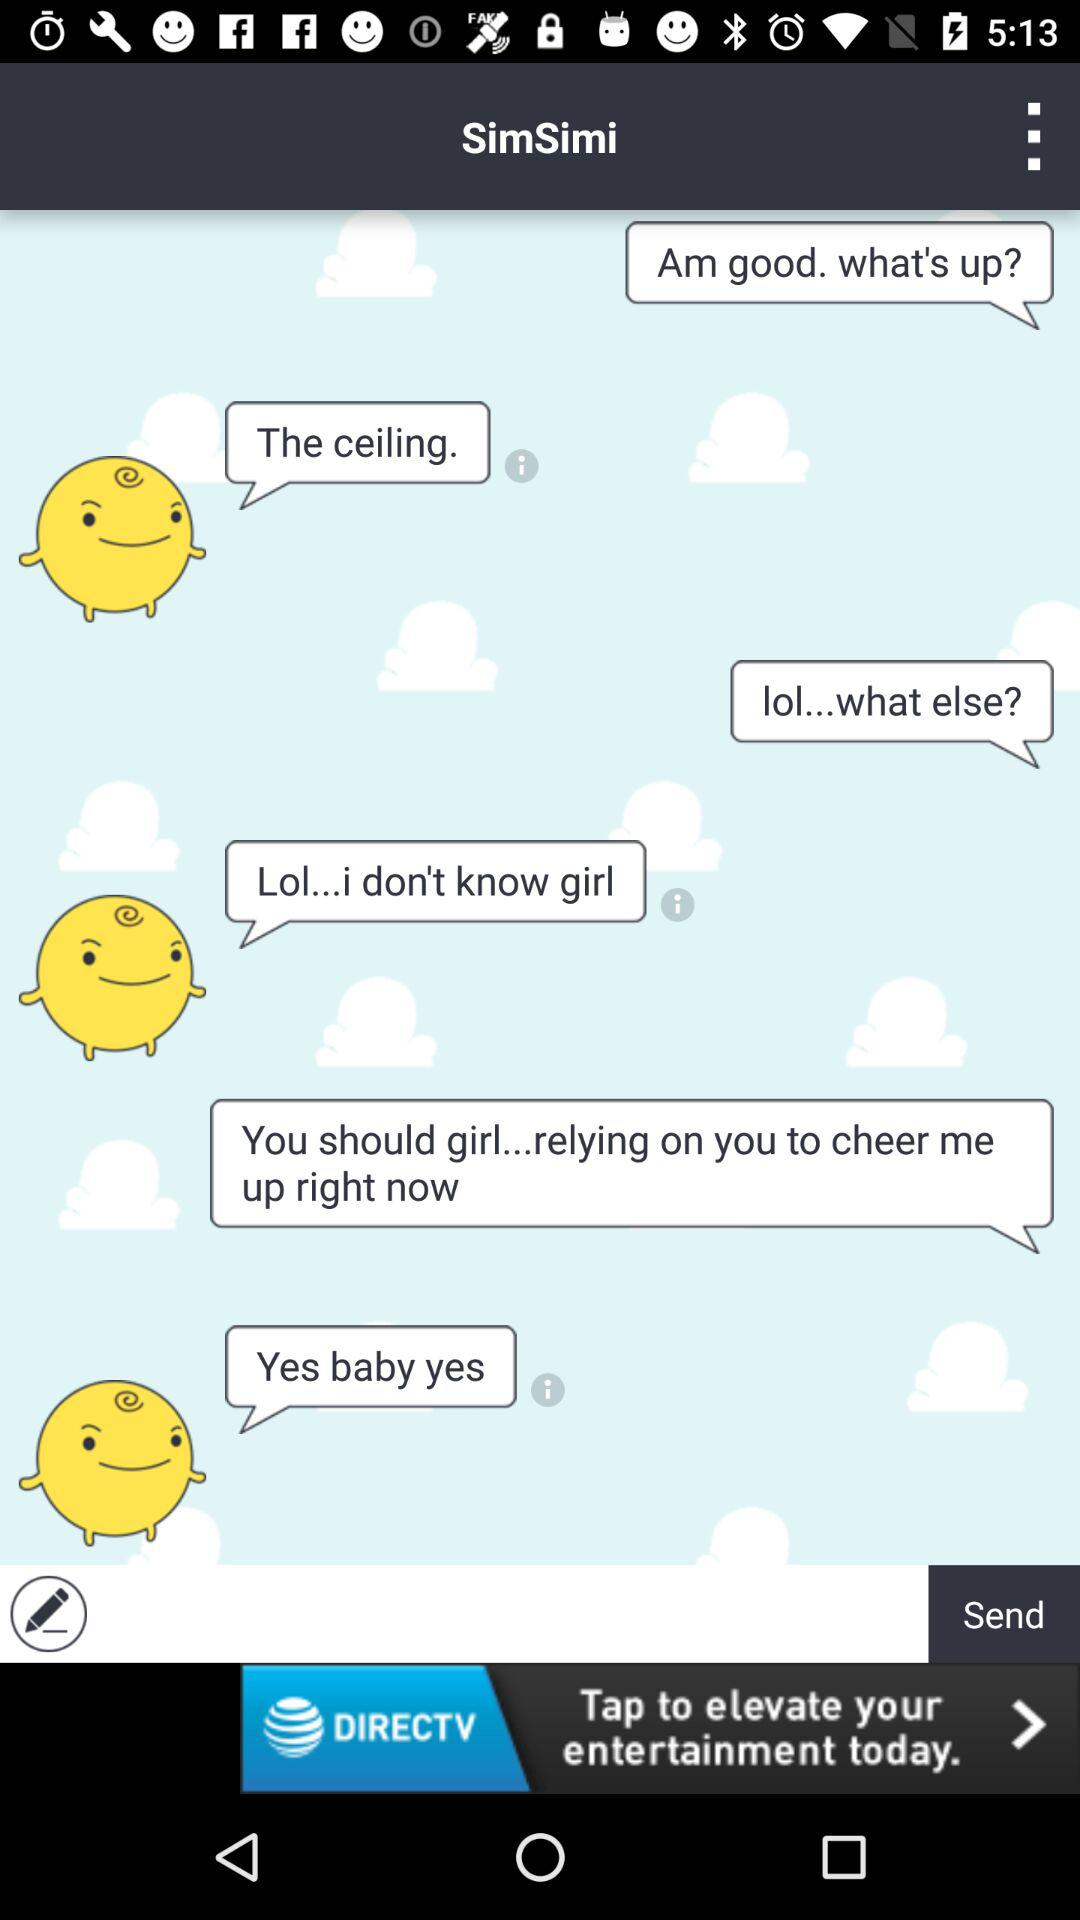How many smiley faces with swirls on their heads are there?
Answer the question using a single word or phrase. 3 